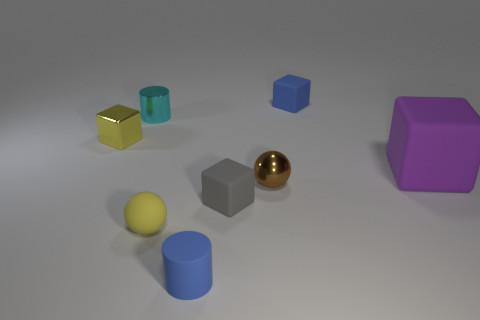There is a large matte block; how many tiny cyan cylinders are right of it?
Your answer should be compact. 0. There is a tiny object to the right of the ball that is behind the gray rubber block; what is its shape?
Your answer should be very brief. Cube. Are there more tiny gray objects in front of the purple matte block than tiny brown cylinders?
Provide a short and direct response. Yes. There is a small brown metal thing behind the small blue matte cylinder; how many small yellow cubes are on the left side of it?
Your answer should be very brief. 1. What is the shape of the tiny blue rubber thing that is to the left of the sphere right of the yellow thing that is in front of the large purple matte thing?
Keep it short and to the point. Cylinder. The cyan metallic thing has what size?
Your response must be concise. Small. Is there a brown cube made of the same material as the tiny yellow sphere?
Provide a succinct answer. No. There is another thing that is the same shape as the tiny yellow matte object; what is its size?
Provide a succinct answer. Small. Are there the same number of metal things that are behind the yellow metal cube and small cyan shiny cylinders?
Your response must be concise. Yes. There is a blue matte thing on the right side of the small gray object; does it have the same shape as the tiny yellow metal thing?
Provide a short and direct response. Yes. 